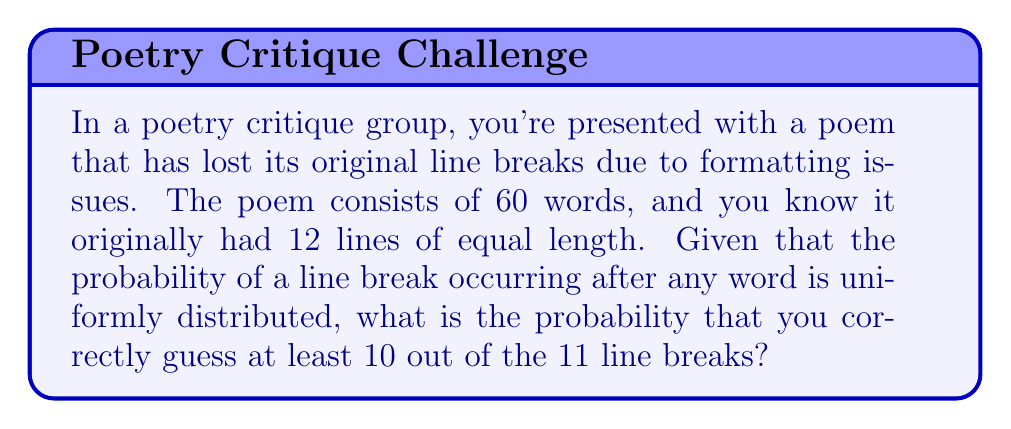Solve this math problem. Let's approach this step-by-step:

1) First, we need to calculate the total number of possible ways to place 11 line breaks among 59 spaces between words. This is a combination problem:

   $$\binom{59}{11}$$

2) Now, we need to calculate the number of ways to correctly guess at least 10 out of 11 line breaks. This can be broken down into two cases:
   a) Correctly guessing all 11 line breaks
   b) Correctly guessing exactly 10 out of 11 line breaks

3) For case a, there's only one way to guess all 11 correctly:

   $$\binom{11}{11} = 1$$

4) For case b, we need to choose which 10 out of 11 line breaks we guess correctly, and then choose 1 incorrect position out of the remaining 48 spaces:

   $$\binom{11}{10} \cdot \binom{48}{1} = 11 \cdot 48 = 528$$

5) The total number of favorable outcomes is the sum of cases a and b:

   $$1 + 528 = 529$$

6) The probability is then the number of favorable outcomes divided by the total number of possible outcomes:

   $$P = \frac{529}{\binom{59}{11}}$$

7) Calculating this:
   
   $$P = \frac{529}{5.47 \times 10^{11}} \approx 9.67 \times 10^{-10}$$
Answer: $9.67 \times 10^{-10}$ 